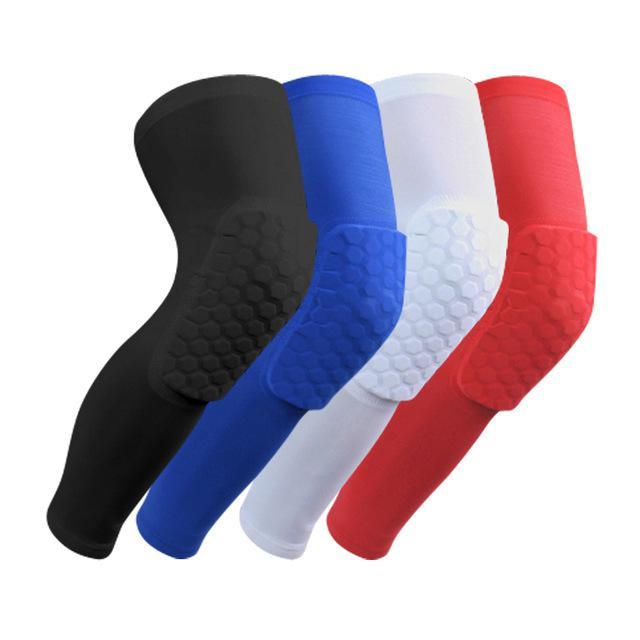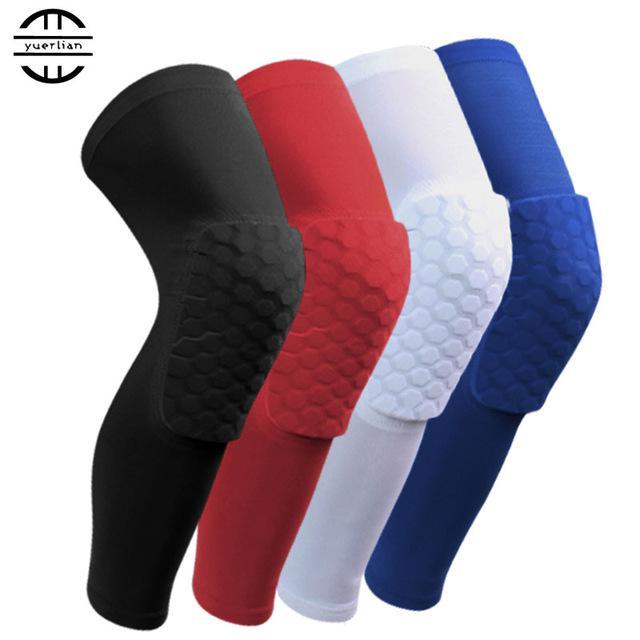The first image is the image on the left, the second image is the image on the right. Evaluate the accuracy of this statement regarding the images: "Eight compression socks with knee pads are visible.". Is it true? Answer yes or no. Yes. The first image is the image on the left, the second image is the image on the right. Assess this claim about the two images: "The right image shows 4 knee guards facing to the right.". Correct or not? Answer yes or no. Yes. 